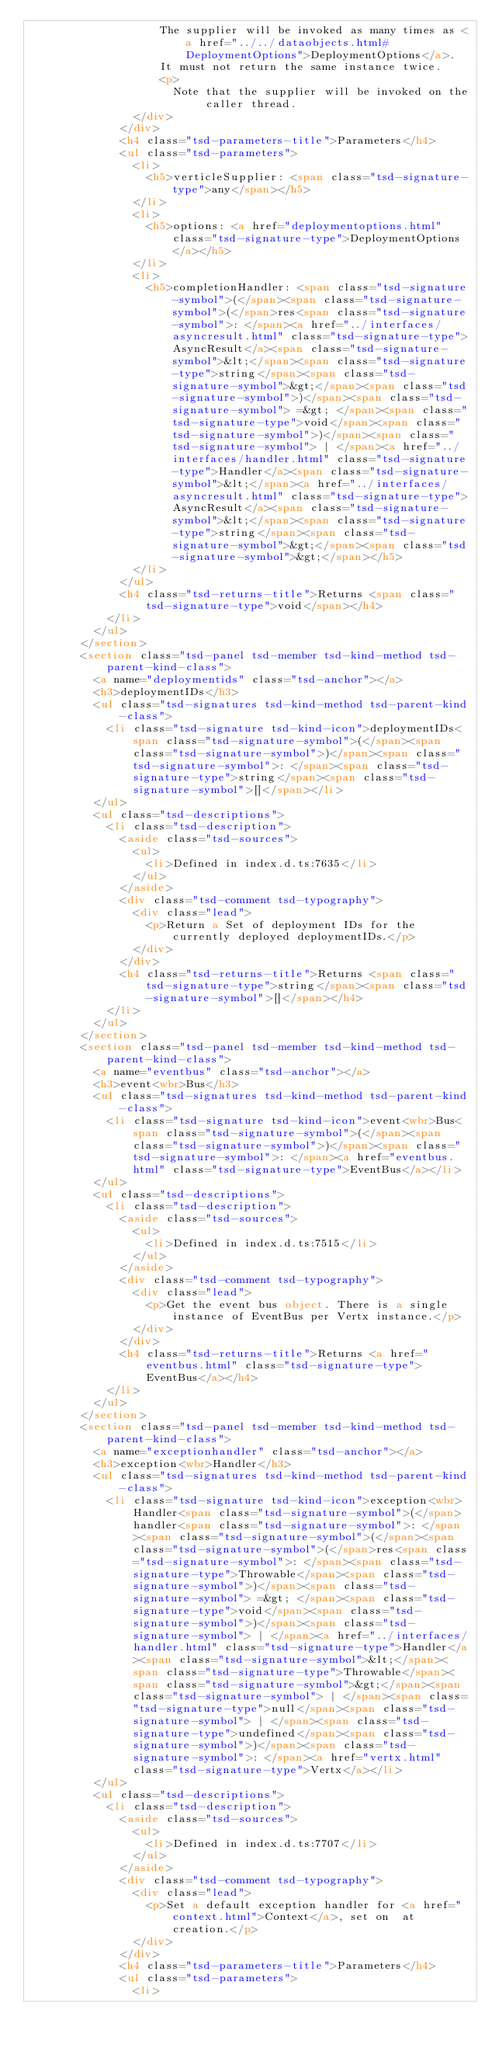Convert code to text. <code><loc_0><loc_0><loc_500><loc_500><_HTML_>										The supplier will be invoked as many times as <a href="../../dataobjects.html#DeploymentOptions">DeploymentOptions</a>.
										It must not return the same instance twice.
										<p>
											Note that the supplier will be invoked on the caller thread.
								</div>
							</div>
							<h4 class="tsd-parameters-title">Parameters</h4>
							<ul class="tsd-parameters">
								<li>
									<h5>verticleSupplier: <span class="tsd-signature-type">any</span></h5>
								</li>
								<li>
									<h5>options: <a href="deploymentoptions.html" class="tsd-signature-type">DeploymentOptions</a></h5>
								</li>
								<li>
									<h5>completionHandler: <span class="tsd-signature-symbol">(</span><span class="tsd-signature-symbol">(</span>res<span class="tsd-signature-symbol">: </span><a href="../interfaces/asyncresult.html" class="tsd-signature-type">AsyncResult</a><span class="tsd-signature-symbol">&lt;</span><span class="tsd-signature-type">string</span><span class="tsd-signature-symbol">&gt;</span><span class="tsd-signature-symbol">)</span><span class="tsd-signature-symbol"> =&gt; </span><span class="tsd-signature-type">void</span><span class="tsd-signature-symbol">)</span><span class="tsd-signature-symbol"> | </span><a href="../interfaces/handler.html" class="tsd-signature-type">Handler</a><span class="tsd-signature-symbol">&lt;</span><a href="../interfaces/asyncresult.html" class="tsd-signature-type">AsyncResult</a><span class="tsd-signature-symbol">&lt;</span><span class="tsd-signature-type">string</span><span class="tsd-signature-symbol">&gt;</span><span class="tsd-signature-symbol">&gt;</span></h5>
								</li>
							</ul>
							<h4 class="tsd-returns-title">Returns <span class="tsd-signature-type">void</span></h4>
						</li>
					</ul>
				</section>
				<section class="tsd-panel tsd-member tsd-kind-method tsd-parent-kind-class">
					<a name="deploymentids" class="tsd-anchor"></a>
					<h3>deploymentIDs</h3>
					<ul class="tsd-signatures tsd-kind-method tsd-parent-kind-class">
						<li class="tsd-signature tsd-kind-icon">deploymentIDs<span class="tsd-signature-symbol">(</span><span class="tsd-signature-symbol">)</span><span class="tsd-signature-symbol">: </span><span class="tsd-signature-type">string</span><span class="tsd-signature-symbol">[]</span></li>
					</ul>
					<ul class="tsd-descriptions">
						<li class="tsd-description">
							<aside class="tsd-sources">
								<ul>
									<li>Defined in index.d.ts:7635</li>
								</ul>
							</aside>
							<div class="tsd-comment tsd-typography">
								<div class="lead">
									<p>Return a Set of deployment IDs for the currently deployed deploymentIDs.</p>
								</div>
							</div>
							<h4 class="tsd-returns-title">Returns <span class="tsd-signature-type">string</span><span class="tsd-signature-symbol">[]</span></h4>
						</li>
					</ul>
				</section>
				<section class="tsd-panel tsd-member tsd-kind-method tsd-parent-kind-class">
					<a name="eventbus" class="tsd-anchor"></a>
					<h3>event<wbr>Bus</h3>
					<ul class="tsd-signatures tsd-kind-method tsd-parent-kind-class">
						<li class="tsd-signature tsd-kind-icon">event<wbr>Bus<span class="tsd-signature-symbol">(</span><span class="tsd-signature-symbol">)</span><span class="tsd-signature-symbol">: </span><a href="eventbus.html" class="tsd-signature-type">EventBus</a></li>
					</ul>
					<ul class="tsd-descriptions">
						<li class="tsd-description">
							<aside class="tsd-sources">
								<ul>
									<li>Defined in index.d.ts:7515</li>
								</ul>
							</aside>
							<div class="tsd-comment tsd-typography">
								<div class="lead">
									<p>Get the event bus object. There is a single instance of EventBus per Vertx instance.</p>
								</div>
							</div>
							<h4 class="tsd-returns-title">Returns <a href="eventbus.html" class="tsd-signature-type">EventBus</a></h4>
						</li>
					</ul>
				</section>
				<section class="tsd-panel tsd-member tsd-kind-method tsd-parent-kind-class">
					<a name="exceptionhandler" class="tsd-anchor"></a>
					<h3>exception<wbr>Handler</h3>
					<ul class="tsd-signatures tsd-kind-method tsd-parent-kind-class">
						<li class="tsd-signature tsd-kind-icon">exception<wbr>Handler<span class="tsd-signature-symbol">(</span>handler<span class="tsd-signature-symbol">: </span><span class="tsd-signature-symbol">(</span><span class="tsd-signature-symbol">(</span>res<span class="tsd-signature-symbol">: </span><span class="tsd-signature-type">Throwable</span><span class="tsd-signature-symbol">)</span><span class="tsd-signature-symbol"> =&gt; </span><span class="tsd-signature-type">void</span><span class="tsd-signature-symbol">)</span><span class="tsd-signature-symbol"> | </span><a href="../interfaces/handler.html" class="tsd-signature-type">Handler</a><span class="tsd-signature-symbol">&lt;</span><span class="tsd-signature-type">Throwable</span><span class="tsd-signature-symbol">&gt;</span><span class="tsd-signature-symbol"> | </span><span class="tsd-signature-type">null</span><span class="tsd-signature-symbol"> | </span><span class="tsd-signature-type">undefined</span><span class="tsd-signature-symbol">)</span><span class="tsd-signature-symbol">: </span><a href="vertx.html" class="tsd-signature-type">Vertx</a></li>
					</ul>
					<ul class="tsd-descriptions">
						<li class="tsd-description">
							<aside class="tsd-sources">
								<ul>
									<li>Defined in index.d.ts:7707</li>
								</ul>
							</aside>
							<div class="tsd-comment tsd-typography">
								<div class="lead">
									<p>Set a default exception handler for <a href="context.html">Context</a>, set on  at creation.</p>
								</div>
							</div>
							<h4 class="tsd-parameters-title">Parameters</h4>
							<ul class="tsd-parameters">
								<li></code> 